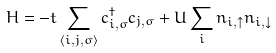Convert formula to latex. <formula><loc_0><loc_0><loc_500><loc_500>H = - t \sum _ { \langle i , j , \sigma \rangle } c ^ { \dagger } _ { i , \sigma } c _ { j , \sigma } + U \sum _ { i } n _ { i , \uparrow } n _ { i , \downarrow }</formula> 